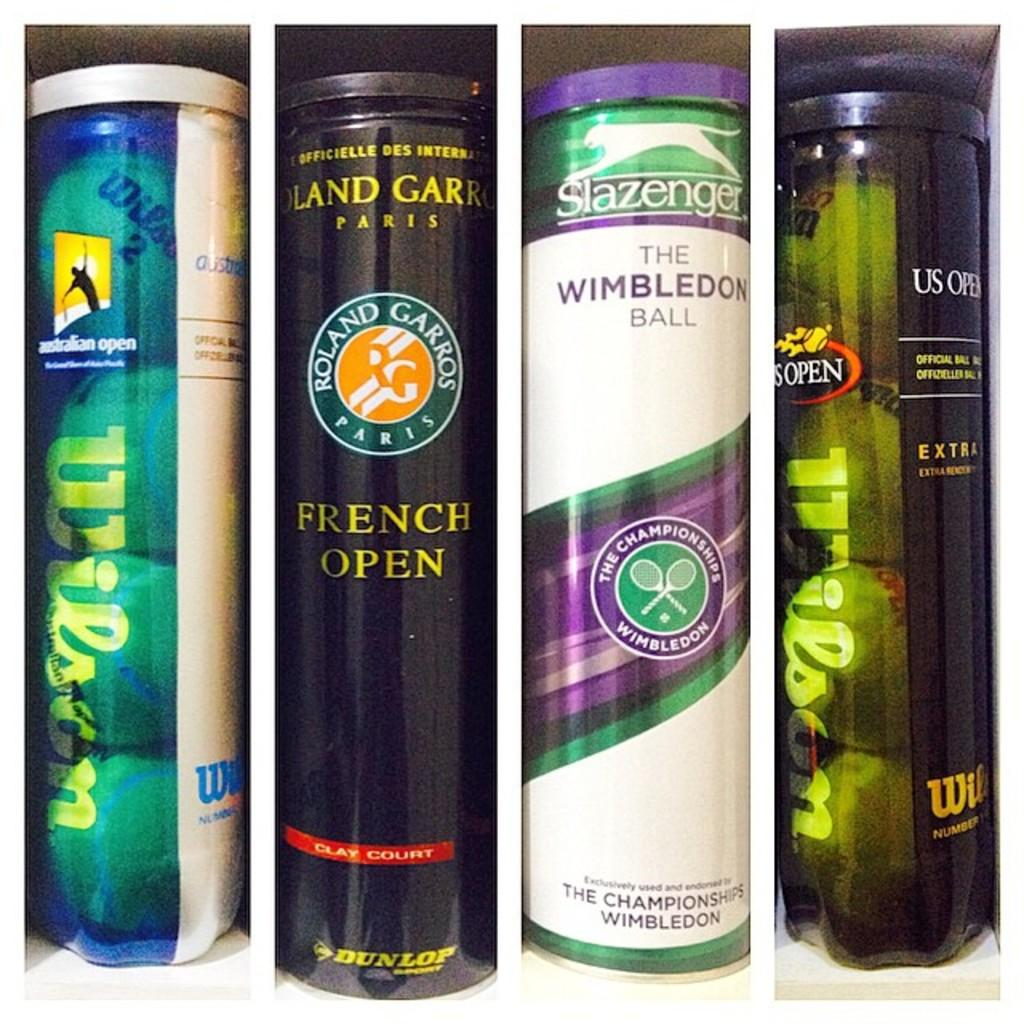Provide a one-sentence caption for the provided image. Two out of the four containers of tennis balls are the Wilson brand. 